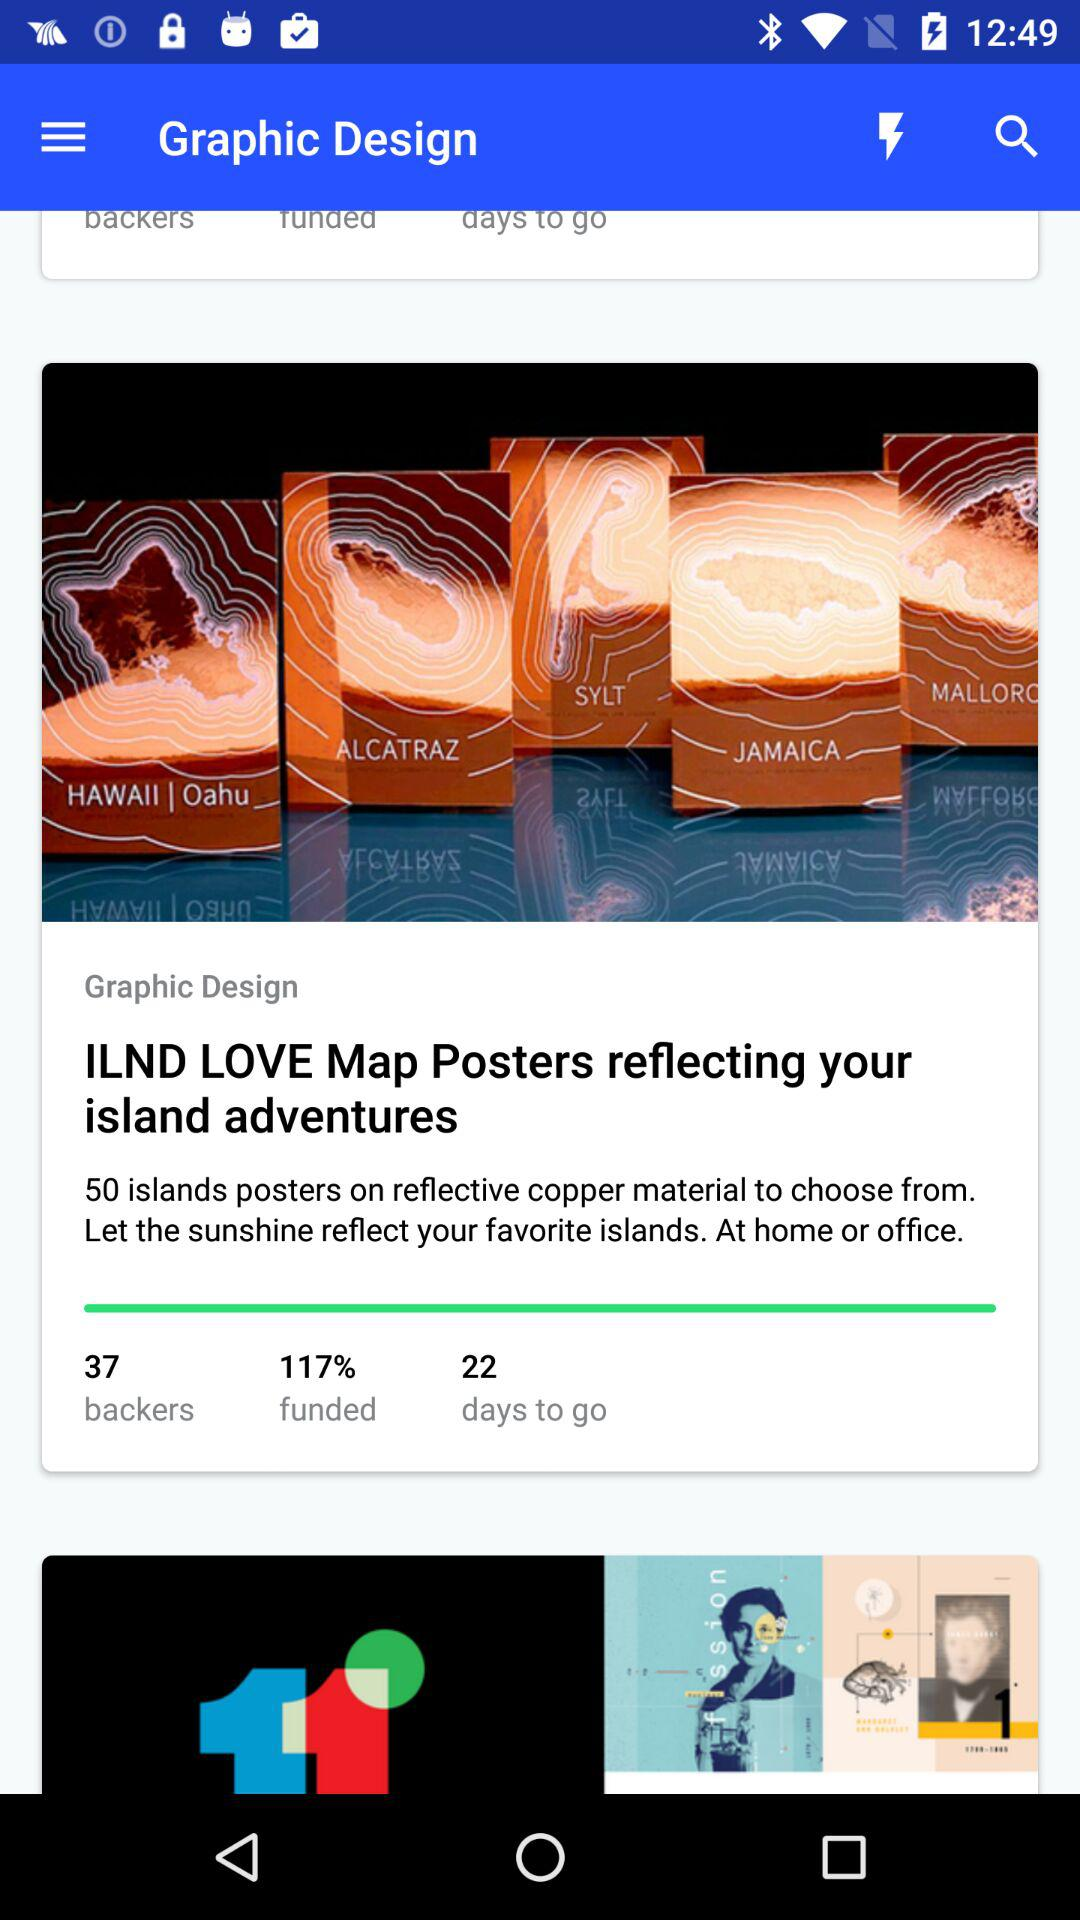How many more days are there left until the project is funded?
Answer the question using a single word or phrase. 22 